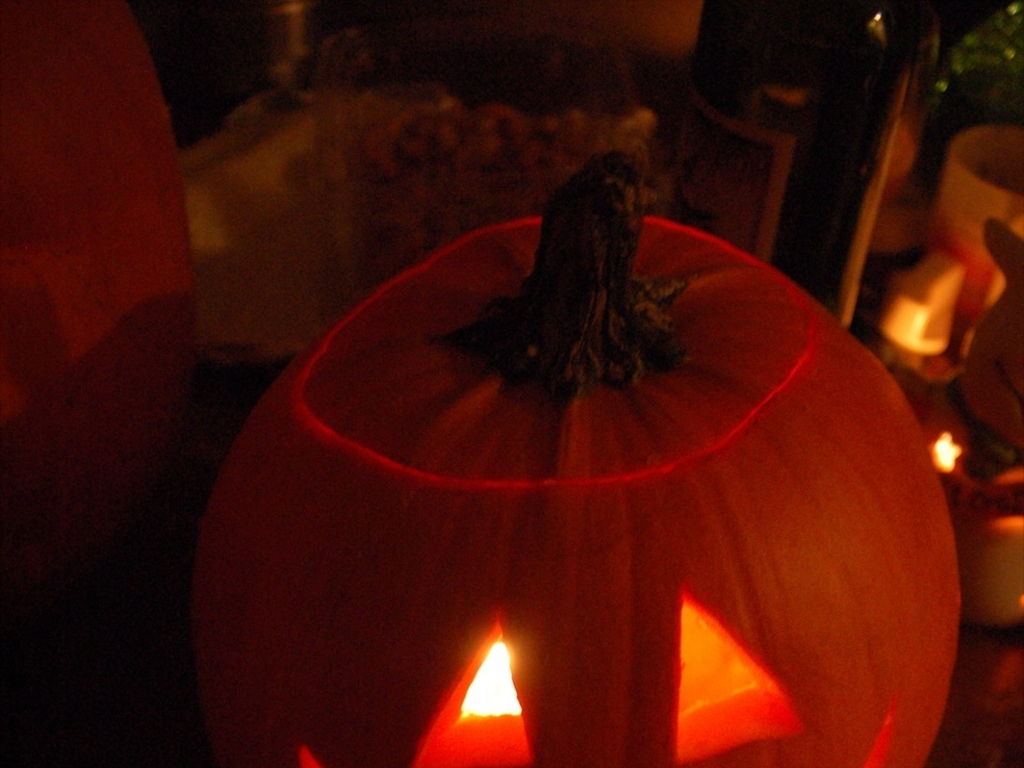Describe the condition and features of the pumpkin used for the lantern. The pumpkin appears to be in good condition, ripe with a vivid orange hue that is characteristic of a well-matured gourd. The stem is stout and intact, signifying freshness. It has been carved meticulously to form triangular eyes and a jagged mouth, through which the internal light casts a traditional Halloween lantern appearance. 